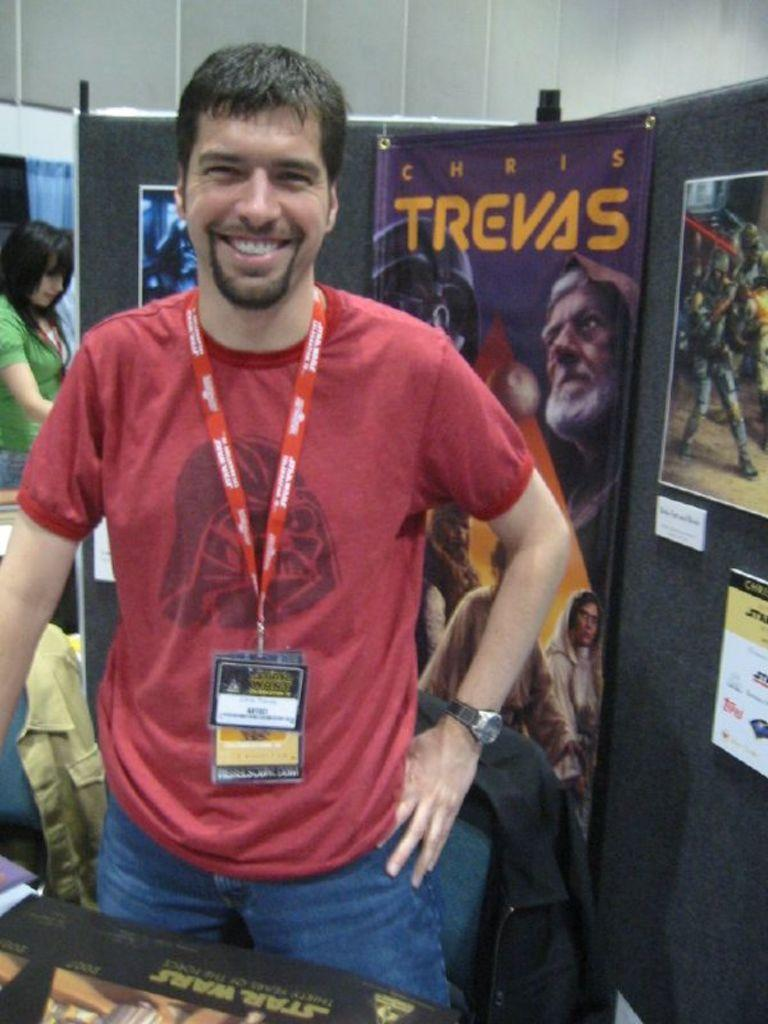<image>
Give a short and clear explanation of the subsequent image. a sheet that has the word Trevas on it 